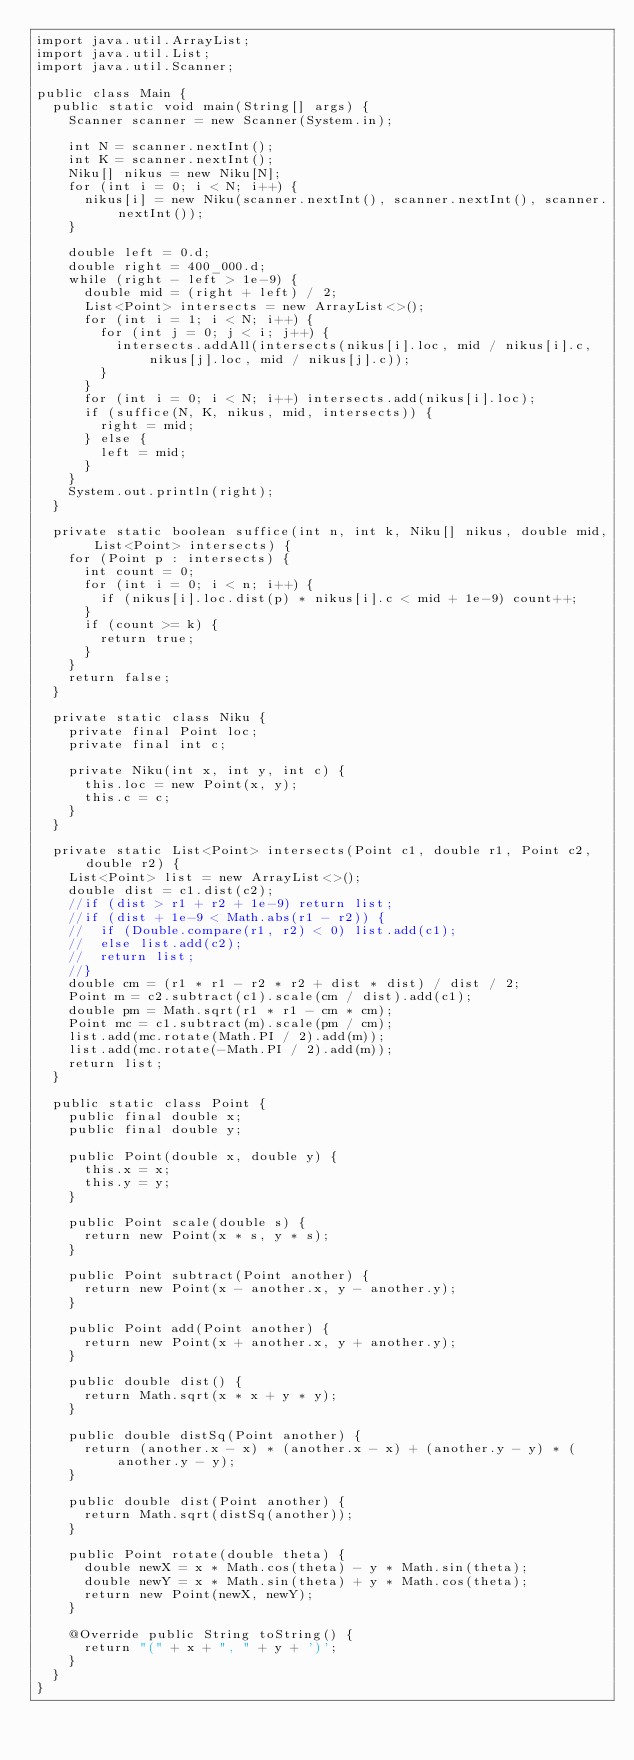Convert code to text. <code><loc_0><loc_0><loc_500><loc_500><_Java_>import java.util.ArrayList;
import java.util.List;
import java.util.Scanner;

public class Main {
  public static void main(String[] args) {
    Scanner scanner = new Scanner(System.in);

    int N = scanner.nextInt();
    int K = scanner.nextInt();
    Niku[] nikus = new Niku[N];
    for (int i = 0; i < N; i++) {
      nikus[i] = new Niku(scanner.nextInt(), scanner.nextInt(), scanner.nextInt());
    }

    double left = 0.d;
    double right = 400_000.d;
    while (right - left > 1e-9) {
      double mid = (right + left) / 2;
      List<Point> intersects = new ArrayList<>();
      for (int i = 1; i < N; i++) {
        for (int j = 0; j < i; j++) {
          intersects.addAll(intersects(nikus[i].loc, mid / nikus[i].c, nikus[j].loc, mid / nikus[j].c));
        }
      }
      for (int i = 0; i < N; i++) intersects.add(nikus[i].loc);
      if (suffice(N, K, nikus, mid, intersects)) {
        right = mid;
      } else {
        left = mid;
      }
    }
    System.out.println(right);
  }

  private static boolean suffice(int n, int k, Niku[] nikus, double mid, List<Point> intersects) {
    for (Point p : intersects) {
      int count = 0;
      for (int i = 0; i < n; i++) {
        if (nikus[i].loc.dist(p) * nikus[i].c < mid + 1e-9) count++;
      }
      if (count >= k) {
        return true;
      }
    }
    return false;
  }

  private static class Niku {
    private final Point loc;
    private final int c;

    private Niku(int x, int y, int c) {
      this.loc = new Point(x, y);
      this.c = c;
    }
  }

  private static List<Point> intersects(Point c1, double r1, Point c2, double r2) {
    List<Point> list = new ArrayList<>();
    double dist = c1.dist(c2);
    //if (dist > r1 + r2 + 1e-9) return list;
    //if (dist + 1e-9 < Math.abs(r1 - r2)) {
    //  if (Double.compare(r1, r2) < 0) list.add(c1);
    //  else list.add(c2);
    //  return list;
    //}
    double cm = (r1 * r1 - r2 * r2 + dist * dist) / dist / 2;
    Point m = c2.subtract(c1).scale(cm / dist).add(c1);
    double pm = Math.sqrt(r1 * r1 - cm * cm);
    Point mc = c1.subtract(m).scale(pm / cm);
    list.add(mc.rotate(Math.PI / 2).add(m));
    list.add(mc.rotate(-Math.PI / 2).add(m));
    return list;
  }

  public static class Point {
    public final double x;
    public final double y;

    public Point(double x, double y) {
      this.x = x;
      this.y = y;
    }

    public Point scale(double s) {
      return new Point(x * s, y * s);
    }

    public Point subtract(Point another) {
      return new Point(x - another.x, y - another.y);
    }

    public Point add(Point another) {
      return new Point(x + another.x, y + another.y);
    }

    public double dist() {
      return Math.sqrt(x * x + y * y);
    }

    public double distSq(Point another) {
      return (another.x - x) * (another.x - x) + (another.y - y) * (another.y - y);
    }

    public double dist(Point another) {
      return Math.sqrt(distSq(another));
    }

    public Point rotate(double theta) {
      double newX = x * Math.cos(theta) - y * Math.sin(theta);
      double newY = x * Math.sin(theta) + y * Math.cos(theta);
      return new Point(newX, newY);
    }

    @Override public String toString() {
      return "(" + x + ", " + y + ')';
    }
  }
}
</code> 